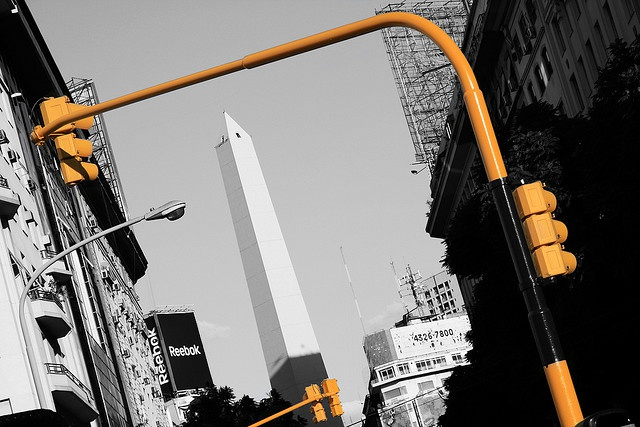Describe the objects in this image and their specific colors. I can see traffic light in black, orange, and maroon tones, traffic light in black, orange, and red tones, traffic light in black, orange, and maroon tones, and traffic light in black, orange, red, and lightgray tones in this image. 